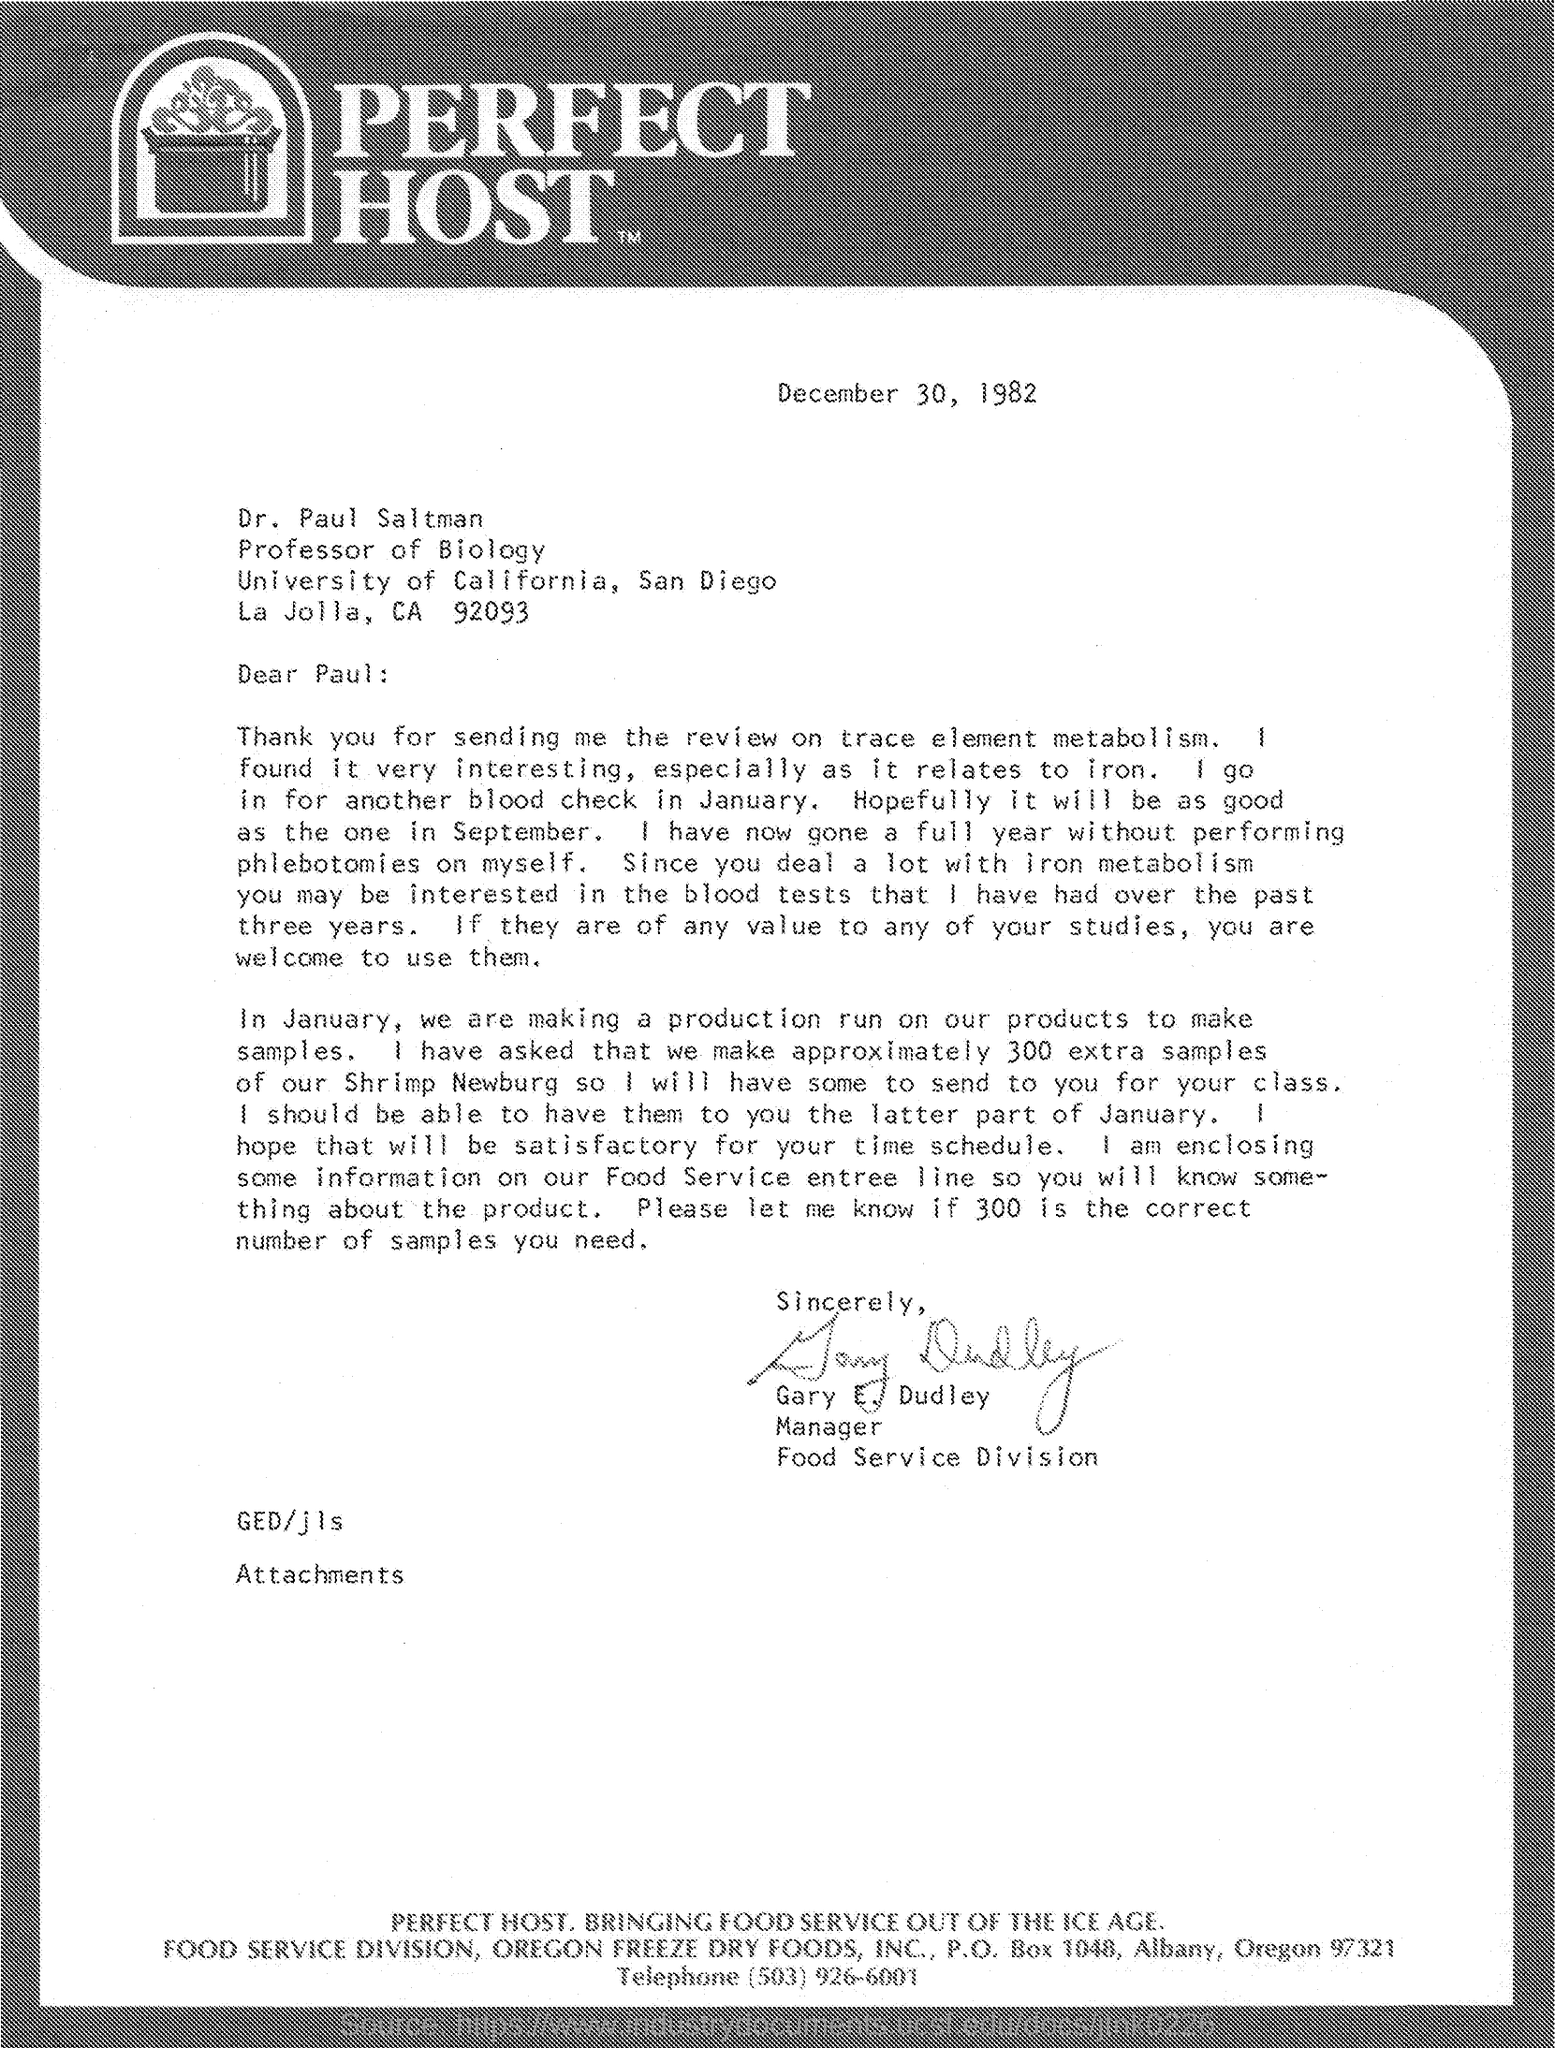Outline some significant characteristics in this image. Gary E. Dudley is the manager of the food service division. The recipient of this letter is Dr. Paul Saltman. The date mentioned is December 30, 1982. 